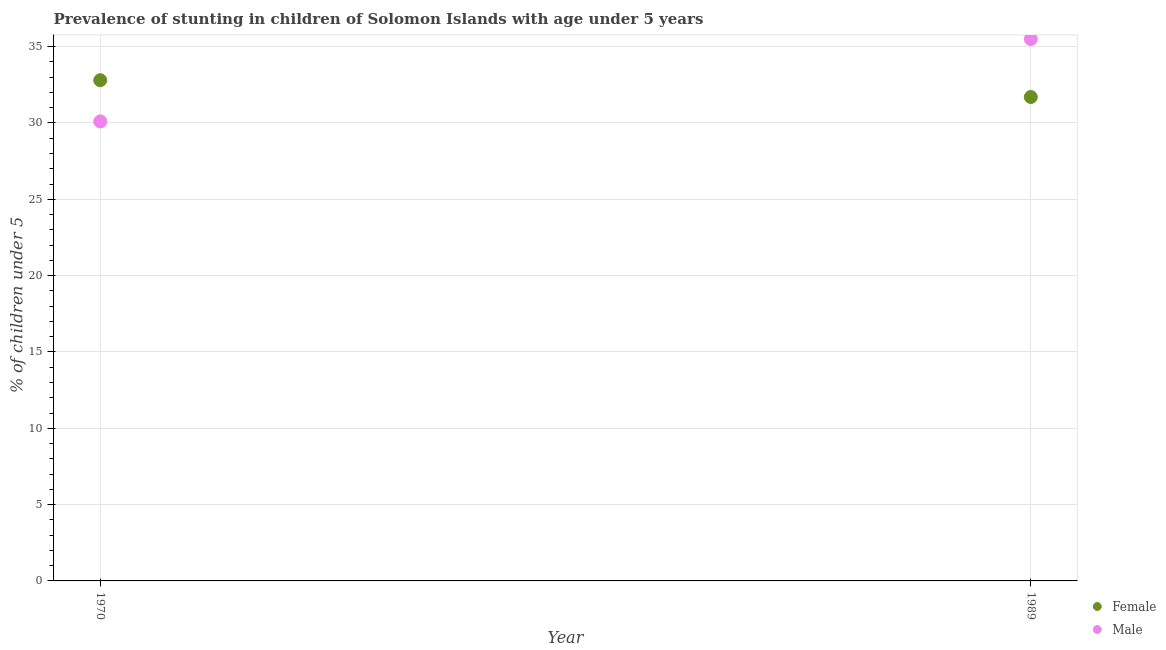Is the number of dotlines equal to the number of legend labels?
Provide a short and direct response. Yes. What is the percentage of stunted female children in 1970?
Provide a short and direct response. 32.8. Across all years, what is the maximum percentage of stunted female children?
Provide a succinct answer. 32.8. Across all years, what is the minimum percentage of stunted male children?
Ensure brevity in your answer.  30.1. In which year was the percentage of stunted male children maximum?
Make the answer very short. 1989. What is the total percentage of stunted female children in the graph?
Provide a short and direct response. 64.5. What is the difference between the percentage of stunted male children in 1970 and that in 1989?
Provide a short and direct response. -5.4. What is the difference between the percentage of stunted male children in 1989 and the percentage of stunted female children in 1970?
Provide a short and direct response. 2.7. What is the average percentage of stunted male children per year?
Your response must be concise. 32.8. In the year 1970, what is the difference between the percentage of stunted male children and percentage of stunted female children?
Offer a terse response. -2.7. What is the ratio of the percentage of stunted male children in 1970 to that in 1989?
Give a very brief answer. 0.85. Is the percentage of stunted male children in 1970 less than that in 1989?
Give a very brief answer. Yes. Does the percentage of stunted male children monotonically increase over the years?
Offer a very short reply. Yes. Is the percentage of stunted female children strictly greater than the percentage of stunted male children over the years?
Provide a short and direct response. No. How many dotlines are there?
Give a very brief answer. 2. How many years are there in the graph?
Provide a succinct answer. 2. What is the difference between two consecutive major ticks on the Y-axis?
Ensure brevity in your answer.  5. What is the title of the graph?
Provide a succinct answer. Prevalence of stunting in children of Solomon Islands with age under 5 years. What is the label or title of the Y-axis?
Provide a short and direct response.  % of children under 5. What is the  % of children under 5 in Female in 1970?
Ensure brevity in your answer.  32.8. What is the  % of children under 5 in Male in 1970?
Your response must be concise. 30.1. What is the  % of children under 5 in Female in 1989?
Your answer should be compact. 31.7. What is the  % of children under 5 in Male in 1989?
Provide a short and direct response. 35.5. Across all years, what is the maximum  % of children under 5 of Female?
Your response must be concise. 32.8. Across all years, what is the maximum  % of children under 5 of Male?
Your answer should be very brief. 35.5. Across all years, what is the minimum  % of children under 5 of Female?
Ensure brevity in your answer.  31.7. Across all years, what is the minimum  % of children under 5 of Male?
Offer a very short reply. 30.1. What is the total  % of children under 5 of Female in the graph?
Offer a very short reply. 64.5. What is the total  % of children under 5 of Male in the graph?
Your answer should be compact. 65.6. What is the difference between the  % of children under 5 in Female in 1970 and that in 1989?
Keep it short and to the point. 1.1. What is the difference between the  % of children under 5 of Male in 1970 and that in 1989?
Offer a very short reply. -5.4. What is the average  % of children under 5 of Female per year?
Offer a terse response. 32.25. What is the average  % of children under 5 in Male per year?
Make the answer very short. 32.8. In the year 1970, what is the difference between the  % of children under 5 of Female and  % of children under 5 of Male?
Keep it short and to the point. 2.7. What is the ratio of the  % of children under 5 in Female in 1970 to that in 1989?
Give a very brief answer. 1.03. What is the ratio of the  % of children under 5 of Male in 1970 to that in 1989?
Your response must be concise. 0.85. What is the difference between the highest and the second highest  % of children under 5 of Female?
Keep it short and to the point. 1.1. 